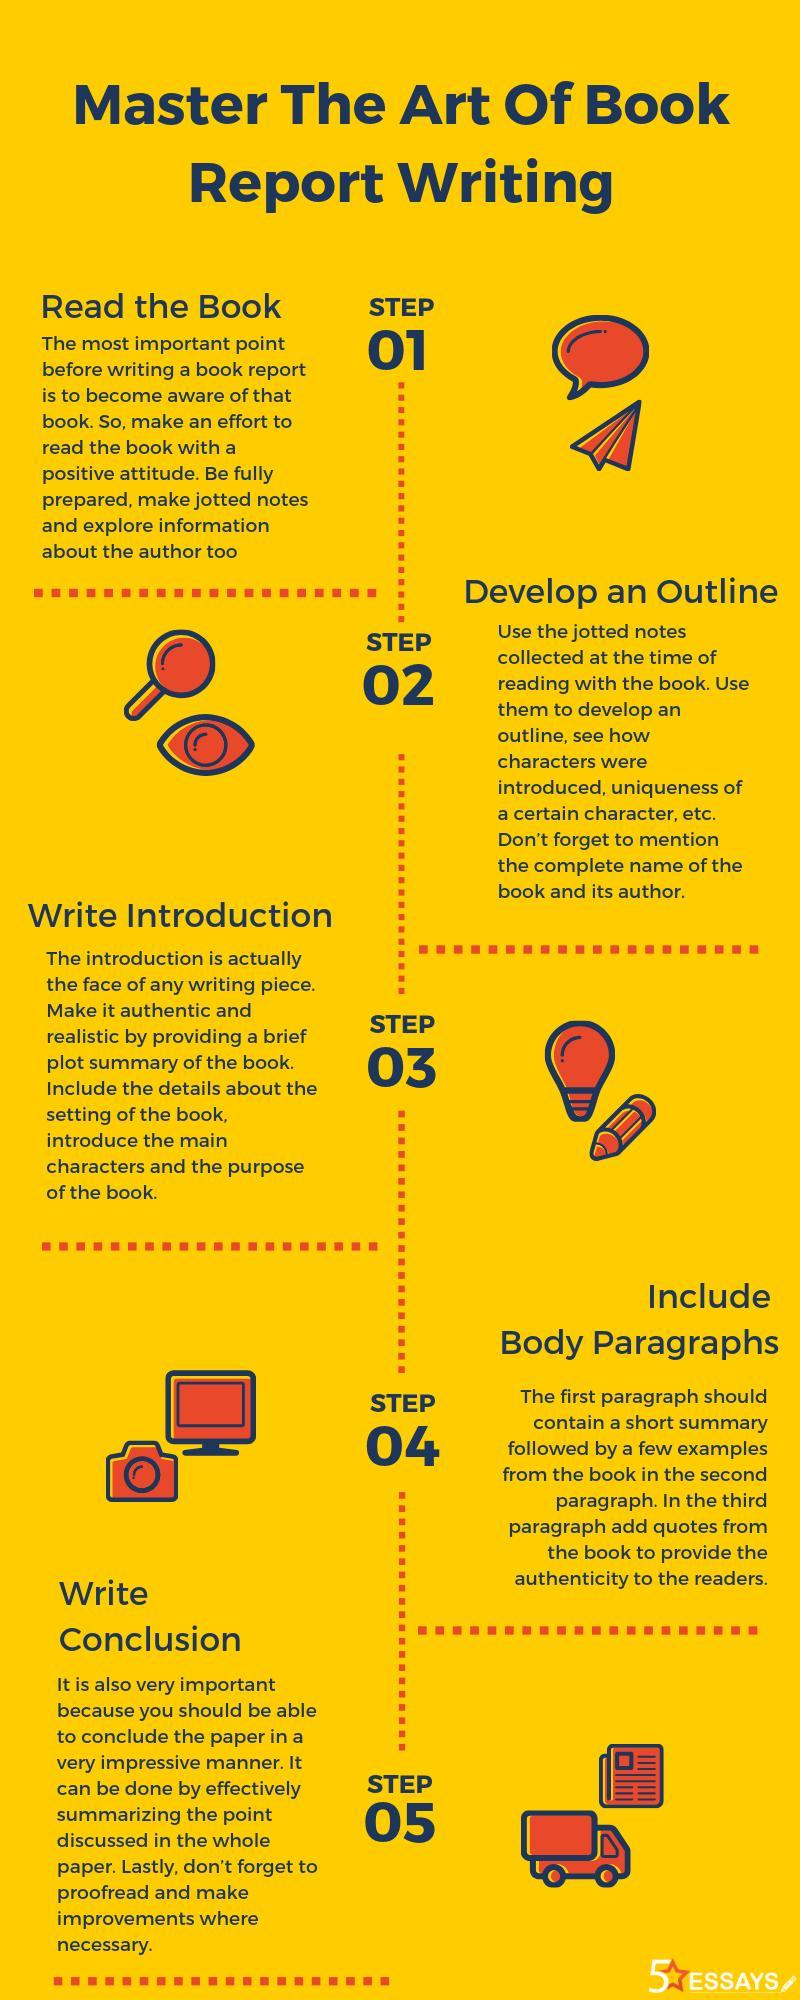What is the 2nd step in this infographic?
Answer the question with a short phrase. Develop an outline How many cameras are in this infographic? 1 What is the 3rd step in this infographic? Write Introduction What is the 4th step in this infographic? Include body paragraphs 